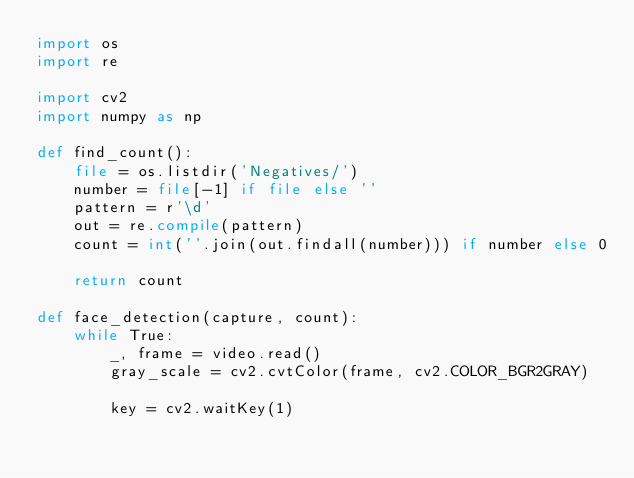<code> <loc_0><loc_0><loc_500><loc_500><_Python_>import os
import re

import cv2
import numpy as np

def find_count():
	file = os.listdir('Negatives/')
	number = file[-1] if file else ''
	pattern = r'\d'
	out = re.compile(pattern)
	count = int(''.join(out.findall(number))) if number else 0

	return count

def face_detection(capture, count):
	while True:
		_, frame = video.read()
		gray_scale = cv2.cvtColor(frame, cv2.COLOR_BGR2GRAY)

		key = cv2.waitKey(1)</code> 